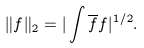<formula> <loc_0><loc_0><loc_500><loc_500>\| f \| _ { 2 } = | \int \overline { f } f | ^ { 1 / 2 } .</formula> 